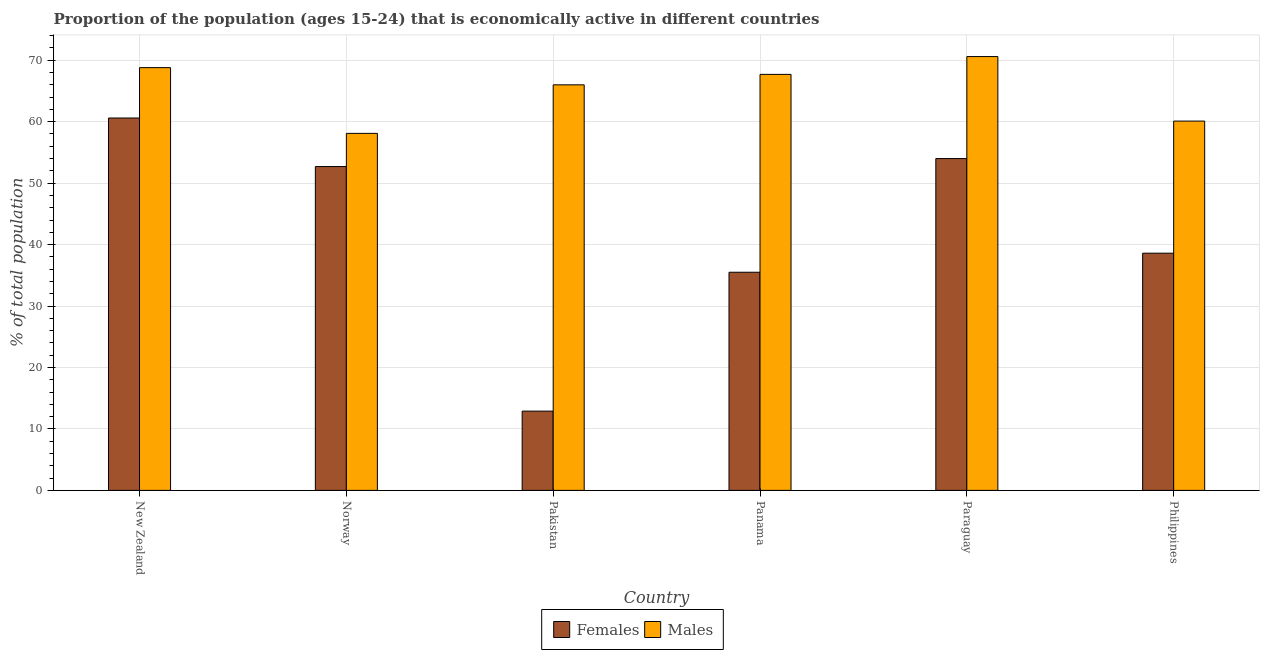Are the number of bars per tick equal to the number of legend labels?
Offer a very short reply. Yes. How many bars are there on the 2nd tick from the right?
Give a very brief answer. 2. What is the label of the 5th group of bars from the left?
Your response must be concise. Paraguay. In how many cases, is the number of bars for a given country not equal to the number of legend labels?
Offer a very short reply. 0. What is the percentage of economically active male population in Panama?
Offer a terse response. 67.7. Across all countries, what is the maximum percentage of economically active male population?
Offer a terse response. 70.6. Across all countries, what is the minimum percentage of economically active female population?
Your answer should be very brief. 12.9. In which country was the percentage of economically active male population maximum?
Your response must be concise. Paraguay. What is the total percentage of economically active male population in the graph?
Offer a terse response. 391.3. What is the difference between the percentage of economically active female population in New Zealand and that in Norway?
Offer a very short reply. 7.9. What is the difference between the percentage of economically active male population in New Zealand and the percentage of economically active female population in Panama?
Keep it short and to the point. 33.3. What is the average percentage of economically active male population per country?
Offer a very short reply. 65.22. What is the difference between the percentage of economically active female population and percentage of economically active male population in Panama?
Offer a terse response. -32.2. What is the ratio of the percentage of economically active male population in Paraguay to that in Philippines?
Your response must be concise. 1.17. What is the difference between the highest and the second highest percentage of economically active female population?
Offer a very short reply. 6.6. What is the difference between the highest and the lowest percentage of economically active female population?
Provide a short and direct response. 47.7. What does the 1st bar from the left in Paraguay represents?
Provide a short and direct response. Females. What does the 1st bar from the right in Norway represents?
Give a very brief answer. Males. How many bars are there?
Offer a very short reply. 12. What is the difference between two consecutive major ticks on the Y-axis?
Offer a very short reply. 10. Does the graph contain any zero values?
Provide a short and direct response. No. Does the graph contain grids?
Ensure brevity in your answer.  Yes. Where does the legend appear in the graph?
Your answer should be very brief. Bottom center. How many legend labels are there?
Offer a terse response. 2. How are the legend labels stacked?
Offer a terse response. Horizontal. What is the title of the graph?
Give a very brief answer. Proportion of the population (ages 15-24) that is economically active in different countries. Does "Quasi money growth" appear as one of the legend labels in the graph?
Your answer should be compact. No. What is the label or title of the Y-axis?
Ensure brevity in your answer.  % of total population. What is the % of total population in Females in New Zealand?
Provide a short and direct response. 60.6. What is the % of total population of Males in New Zealand?
Offer a very short reply. 68.8. What is the % of total population of Females in Norway?
Keep it short and to the point. 52.7. What is the % of total population of Males in Norway?
Provide a succinct answer. 58.1. What is the % of total population of Females in Pakistan?
Your response must be concise. 12.9. What is the % of total population of Males in Pakistan?
Provide a short and direct response. 66. What is the % of total population in Females in Panama?
Provide a succinct answer. 35.5. What is the % of total population of Males in Panama?
Give a very brief answer. 67.7. What is the % of total population in Males in Paraguay?
Make the answer very short. 70.6. What is the % of total population in Females in Philippines?
Keep it short and to the point. 38.6. What is the % of total population of Males in Philippines?
Your answer should be very brief. 60.1. Across all countries, what is the maximum % of total population in Females?
Your answer should be very brief. 60.6. Across all countries, what is the maximum % of total population of Males?
Offer a very short reply. 70.6. Across all countries, what is the minimum % of total population in Females?
Your response must be concise. 12.9. Across all countries, what is the minimum % of total population in Males?
Ensure brevity in your answer.  58.1. What is the total % of total population in Females in the graph?
Provide a succinct answer. 254.3. What is the total % of total population of Males in the graph?
Keep it short and to the point. 391.3. What is the difference between the % of total population of Females in New Zealand and that in Pakistan?
Offer a terse response. 47.7. What is the difference between the % of total population of Females in New Zealand and that in Panama?
Offer a very short reply. 25.1. What is the difference between the % of total population in Females in New Zealand and that in Paraguay?
Give a very brief answer. 6.6. What is the difference between the % of total population of Males in New Zealand and that in Paraguay?
Give a very brief answer. -1.8. What is the difference between the % of total population in Males in New Zealand and that in Philippines?
Provide a succinct answer. 8.7. What is the difference between the % of total population of Females in Norway and that in Pakistan?
Make the answer very short. 39.8. What is the difference between the % of total population of Males in Norway and that in Pakistan?
Keep it short and to the point. -7.9. What is the difference between the % of total population of Females in Norway and that in Panama?
Your response must be concise. 17.2. What is the difference between the % of total population of Females in Norway and that in Paraguay?
Keep it short and to the point. -1.3. What is the difference between the % of total population of Females in Pakistan and that in Panama?
Your response must be concise. -22.6. What is the difference between the % of total population of Females in Pakistan and that in Paraguay?
Offer a terse response. -41.1. What is the difference between the % of total population in Females in Pakistan and that in Philippines?
Keep it short and to the point. -25.7. What is the difference between the % of total population of Females in Panama and that in Paraguay?
Provide a short and direct response. -18.5. What is the difference between the % of total population of Females in Panama and that in Philippines?
Provide a short and direct response. -3.1. What is the difference between the % of total population of Females in New Zealand and the % of total population of Males in Norway?
Ensure brevity in your answer.  2.5. What is the difference between the % of total population of Females in New Zealand and the % of total population of Males in Pakistan?
Ensure brevity in your answer.  -5.4. What is the difference between the % of total population in Females in New Zealand and the % of total population in Males in Panama?
Offer a terse response. -7.1. What is the difference between the % of total population in Females in New Zealand and the % of total population in Males in Paraguay?
Offer a terse response. -10. What is the difference between the % of total population of Females in New Zealand and the % of total population of Males in Philippines?
Offer a terse response. 0.5. What is the difference between the % of total population of Females in Norway and the % of total population of Males in Pakistan?
Offer a terse response. -13.3. What is the difference between the % of total population in Females in Norway and the % of total population in Males in Panama?
Offer a very short reply. -15. What is the difference between the % of total population in Females in Norway and the % of total population in Males in Paraguay?
Your answer should be compact. -17.9. What is the difference between the % of total population of Females in Pakistan and the % of total population of Males in Panama?
Your response must be concise. -54.8. What is the difference between the % of total population in Females in Pakistan and the % of total population in Males in Paraguay?
Ensure brevity in your answer.  -57.7. What is the difference between the % of total population of Females in Pakistan and the % of total population of Males in Philippines?
Give a very brief answer. -47.2. What is the difference between the % of total population of Females in Panama and the % of total population of Males in Paraguay?
Make the answer very short. -35.1. What is the difference between the % of total population of Females in Panama and the % of total population of Males in Philippines?
Ensure brevity in your answer.  -24.6. What is the difference between the % of total population of Females in Paraguay and the % of total population of Males in Philippines?
Your answer should be very brief. -6.1. What is the average % of total population of Females per country?
Provide a short and direct response. 42.38. What is the average % of total population of Males per country?
Your response must be concise. 65.22. What is the difference between the % of total population of Females and % of total population of Males in Norway?
Give a very brief answer. -5.4. What is the difference between the % of total population in Females and % of total population in Males in Pakistan?
Your answer should be very brief. -53.1. What is the difference between the % of total population of Females and % of total population of Males in Panama?
Provide a short and direct response. -32.2. What is the difference between the % of total population of Females and % of total population of Males in Paraguay?
Your response must be concise. -16.6. What is the difference between the % of total population of Females and % of total population of Males in Philippines?
Make the answer very short. -21.5. What is the ratio of the % of total population of Females in New Zealand to that in Norway?
Your answer should be compact. 1.15. What is the ratio of the % of total population of Males in New Zealand to that in Norway?
Give a very brief answer. 1.18. What is the ratio of the % of total population of Females in New Zealand to that in Pakistan?
Ensure brevity in your answer.  4.7. What is the ratio of the % of total population in Males in New Zealand to that in Pakistan?
Your answer should be compact. 1.04. What is the ratio of the % of total population of Females in New Zealand to that in Panama?
Your answer should be very brief. 1.71. What is the ratio of the % of total population in Males in New Zealand to that in Panama?
Offer a very short reply. 1.02. What is the ratio of the % of total population in Females in New Zealand to that in Paraguay?
Your answer should be compact. 1.12. What is the ratio of the % of total population of Males in New Zealand to that in Paraguay?
Your answer should be very brief. 0.97. What is the ratio of the % of total population of Females in New Zealand to that in Philippines?
Provide a succinct answer. 1.57. What is the ratio of the % of total population in Males in New Zealand to that in Philippines?
Provide a succinct answer. 1.14. What is the ratio of the % of total population in Females in Norway to that in Pakistan?
Your answer should be very brief. 4.09. What is the ratio of the % of total population in Males in Norway to that in Pakistan?
Your answer should be very brief. 0.88. What is the ratio of the % of total population in Females in Norway to that in Panama?
Offer a terse response. 1.48. What is the ratio of the % of total population of Males in Norway to that in Panama?
Your answer should be very brief. 0.86. What is the ratio of the % of total population in Females in Norway to that in Paraguay?
Offer a terse response. 0.98. What is the ratio of the % of total population in Males in Norway to that in Paraguay?
Offer a terse response. 0.82. What is the ratio of the % of total population of Females in Norway to that in Philippines?
Your response must be concise. 1.37. What is the ratio of the % of total population in Males in Norway to that in Philippines?
Your answer should be compact. 0.97. What is the ratio of the % of total population of Females in Pakistan to that in Panama?
Your response must be concise. 0.36. What is the ratio of the % of total population in Males in Pakistan to that in Panama?
Provide a short and direct response. 0.97. What is the ratio of the % of total population in Females in Pakistan to that in Paraguay?
Offer a very short reply. 0.24. What is the ratio of the % of total population in Males in Pakistan to that in Paraguay?
Provide a short and direct response. 0.93. What is the ratio of the % of total population in Females in Pakistan to that in Philippines?
Offer a very short reply. 0.33. What is the ratio of the % of total population in Males in Pakistan to that in Philippines?
Offer a very short reply. 1.1. What is the ratio of the % of total population in Females in Panama to that in Paraguay?
Provide a succinct answer. 0.66. What is the ratio of the % of total population of Males in Panama to that in Paraguay?
Ensure brevity in your answer.  0.96. What is the ratio of the % of total population in Females in Panama to that in Philippines?
Provide a succinct answer. 0.92. What is the ratio of the % of total population of Males in Panama to that in Philippines?
Keep it short and to the point. 1.13. What is the ratio of the % of total population of Females in Paraguay to that in Philippines?
Give a very brief answer. 1.4. What is the ratio of the % of total population of Males in Paraguay to that in Philippines?
Your response must be concise. 1.17. What is the difference between the highest and the second highest % of total population in Males?
Make the answer very short. 1.8. What is the difference between the highest and the lowest % of total population in Females?
Give a very brief answer. 47.7. 